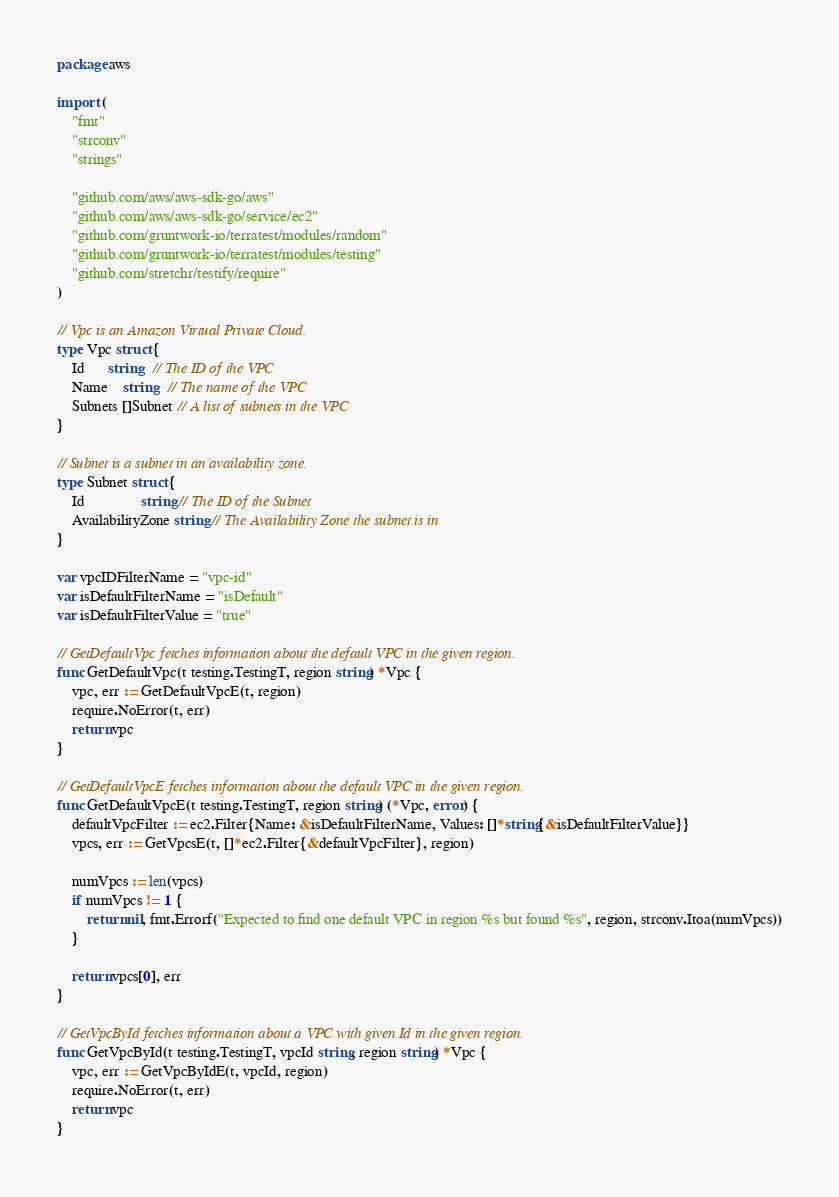<code> <loc_0><loc_0><loc_500><loc_500><_Go_>package aws

import (
	"fmt"
	"strconv"
	"strings"

	"github.com/aws/aws-sdk-go/aws"
	"github.com/aws/aws-sdk-go/service/ec2"
	"github.com/gruntwork-io/terratest/modules/random"
	"github.com/gruntwork-io/terratest/modules/testing"
	"github.com/stretchr/testify/require"
)

// Vpc is an Amazon Virtual Private Cloud.
type Vpc struct {
	Id      string   // The ID of the VPC
	Name    string   // The name of the VPC
	Subnets []Subnet // A list of subnets in the VPC
}

// Subnet is a subnet in an availability zone.
type Subnet struct {
	Id               string // The ID of the Subnet
	AvailabilityZone string // The Availability Zone the subnet is in
}

var vpcIDFilterName = "vpc-id"
var isDefaultFilterName = "isDefault"
var isDefaultFilterValue = "true"

// GetDefaultVpc fetches information about the default VPC in the given region.
func GetDefaultVpc(t testing.TestingT, region string) *Vpc {
	vpc, err := GetDefaultVpcE(t, region)
	require.NoError(t, err)
	return vpc
}

// GetDefaultVpcE fetches information about the default VPC in the given region.
func GetDefaultVpcE(t testing.TestingT, region string) (*Vpc, error) {
	defaultVpcFilter := ec2.Filter{Name: &isDefaultFilterName, Values: []*string{&isDefaultFilterValue}}
	vpcs, err := GetVpcsE(t, []*ec2.Filter{&defaultVpcFilter}, region)

	numVpcs := len(vpcs)
	if numVpcs != 1 {
		return nil, fmt.Errorf("Expected to find one default VPC in region %s but found %s", region, strconv.Itoa(numVpcs))
	}

	return vpcs[0], err
}

// GetVpcById fetches information about a VPC with given Id in the given region.
func GetVpcById(t testing.TestingT, vpcId string, region string) *Vpc {
	vpc, err := GetVpcByIdE(t, vpcId, region)
	require.NoError(t, err)
	return vpc
}
</code> 